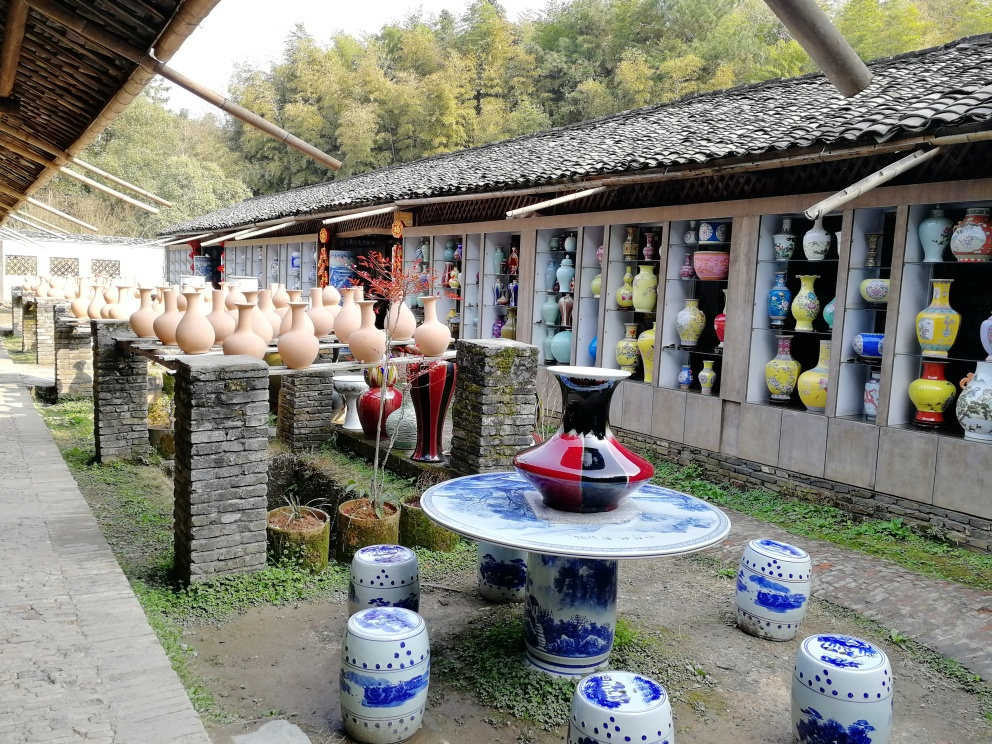Is there any motion blur in the photo? Upon reviewing the image, there is no evidence of motion blur present. All objects, including the various ceramic pots and painted porcelain, appear crisply defined, indicating that the camera was steady at the time of capturing the image, and any moving elements such as leaves or people were static at that moment. 